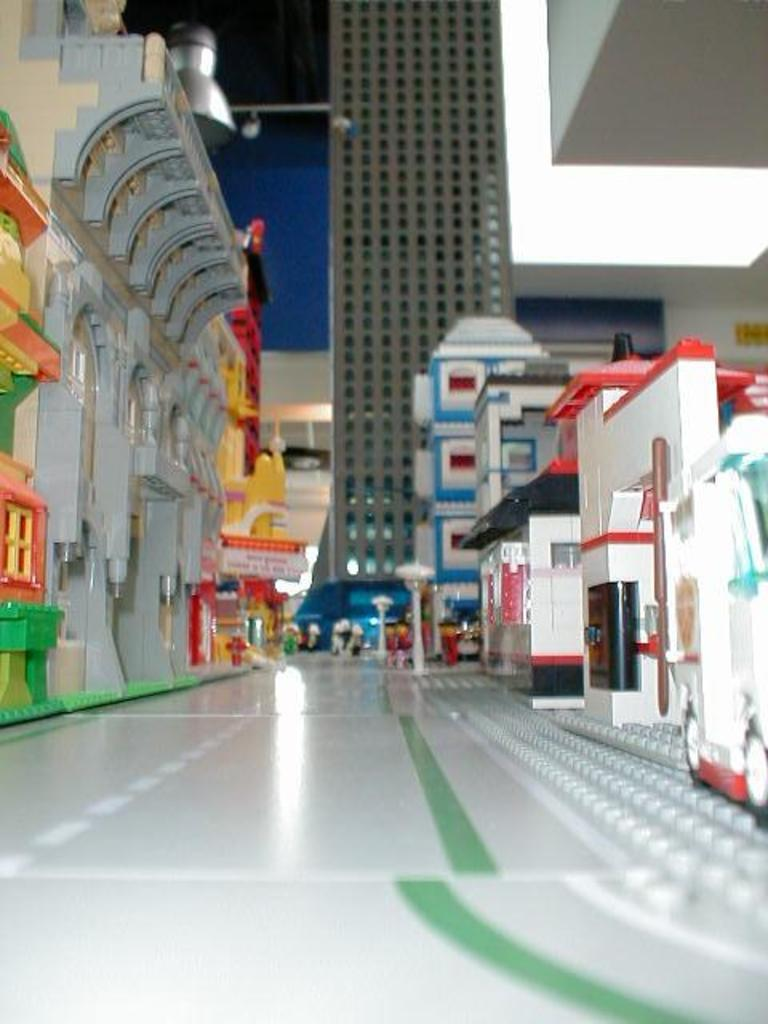What type of objects are featured in the image? There are miniature building models in the image. How many servants are attending to the ice sculpture in the image? There is no ice sculpture or servants present in the image; it features miniature building models. What type of iron is used to create the roof of the building model in the image? There is no iron or roof mentioned in the image; it only features miniature building models. 